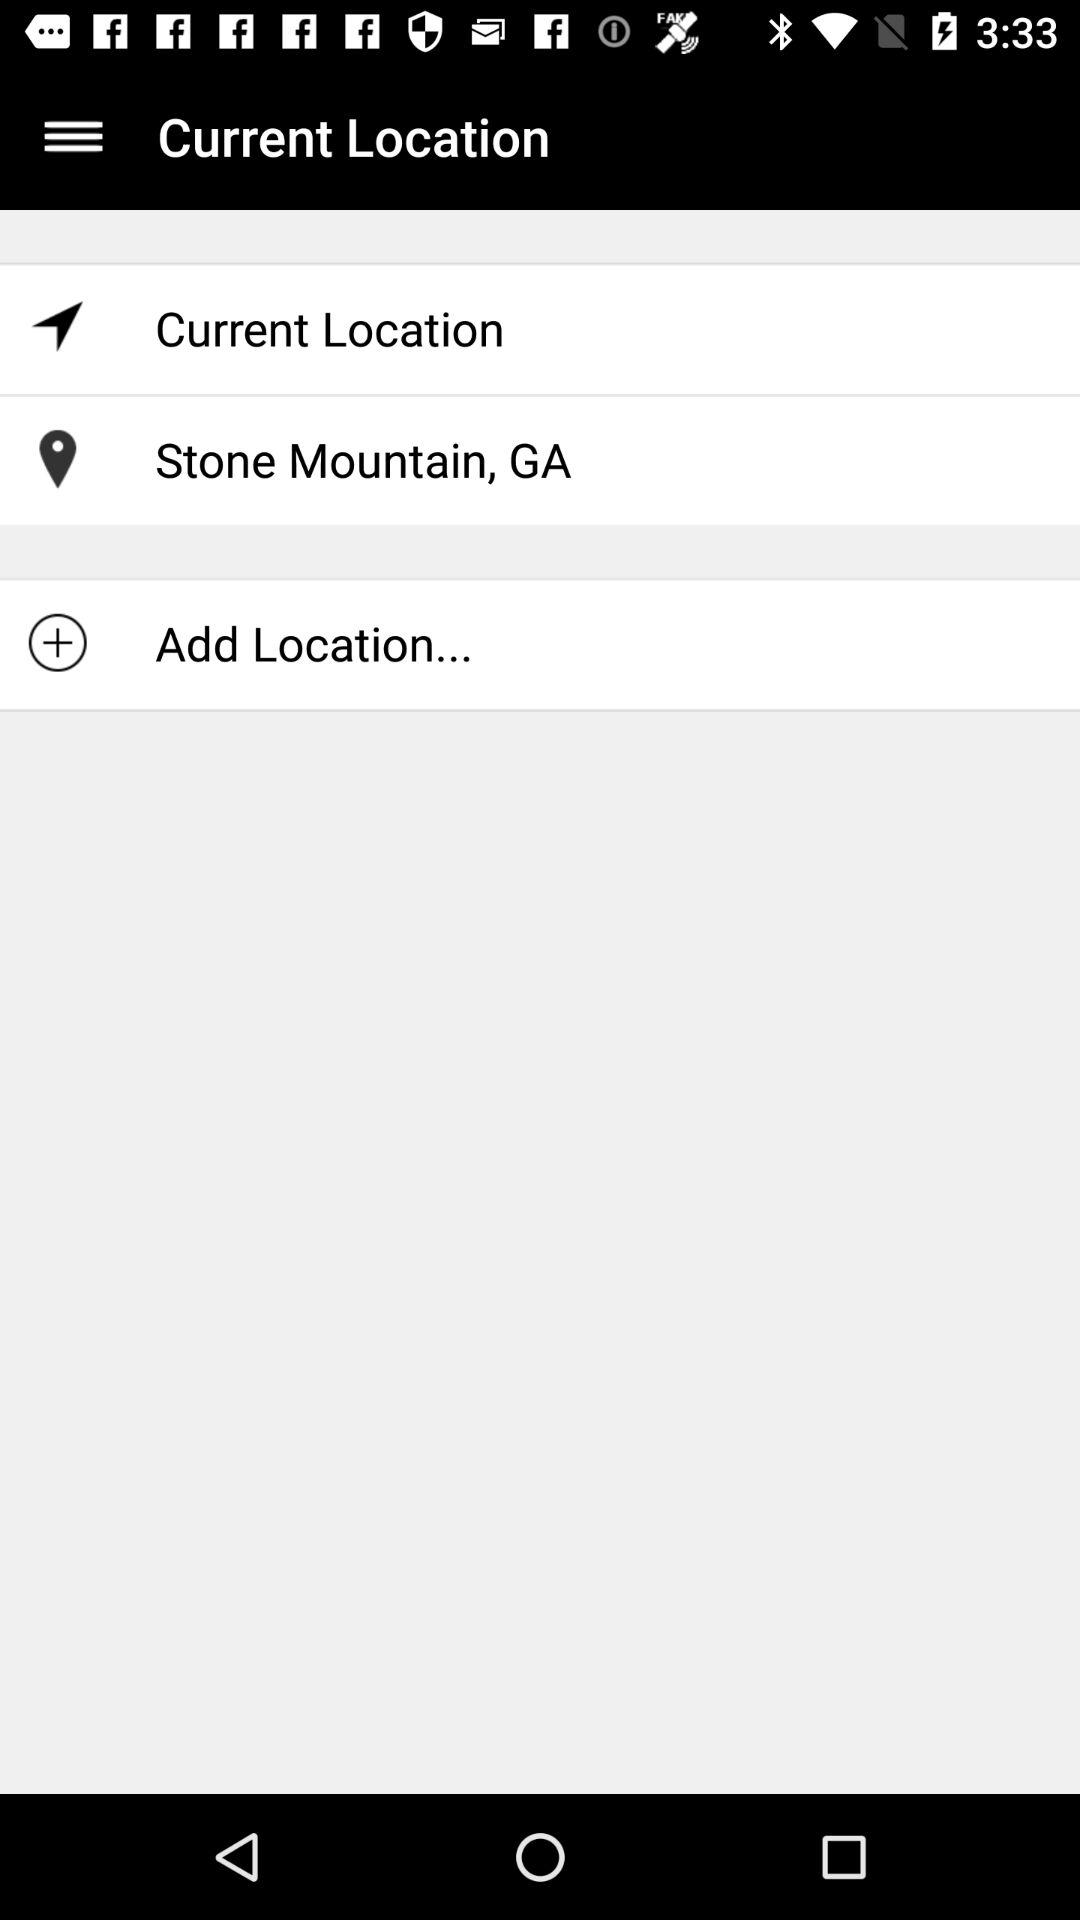Who is this application powered by?
When the provided information is insufficient, respond with <no answer>. <no answer> 